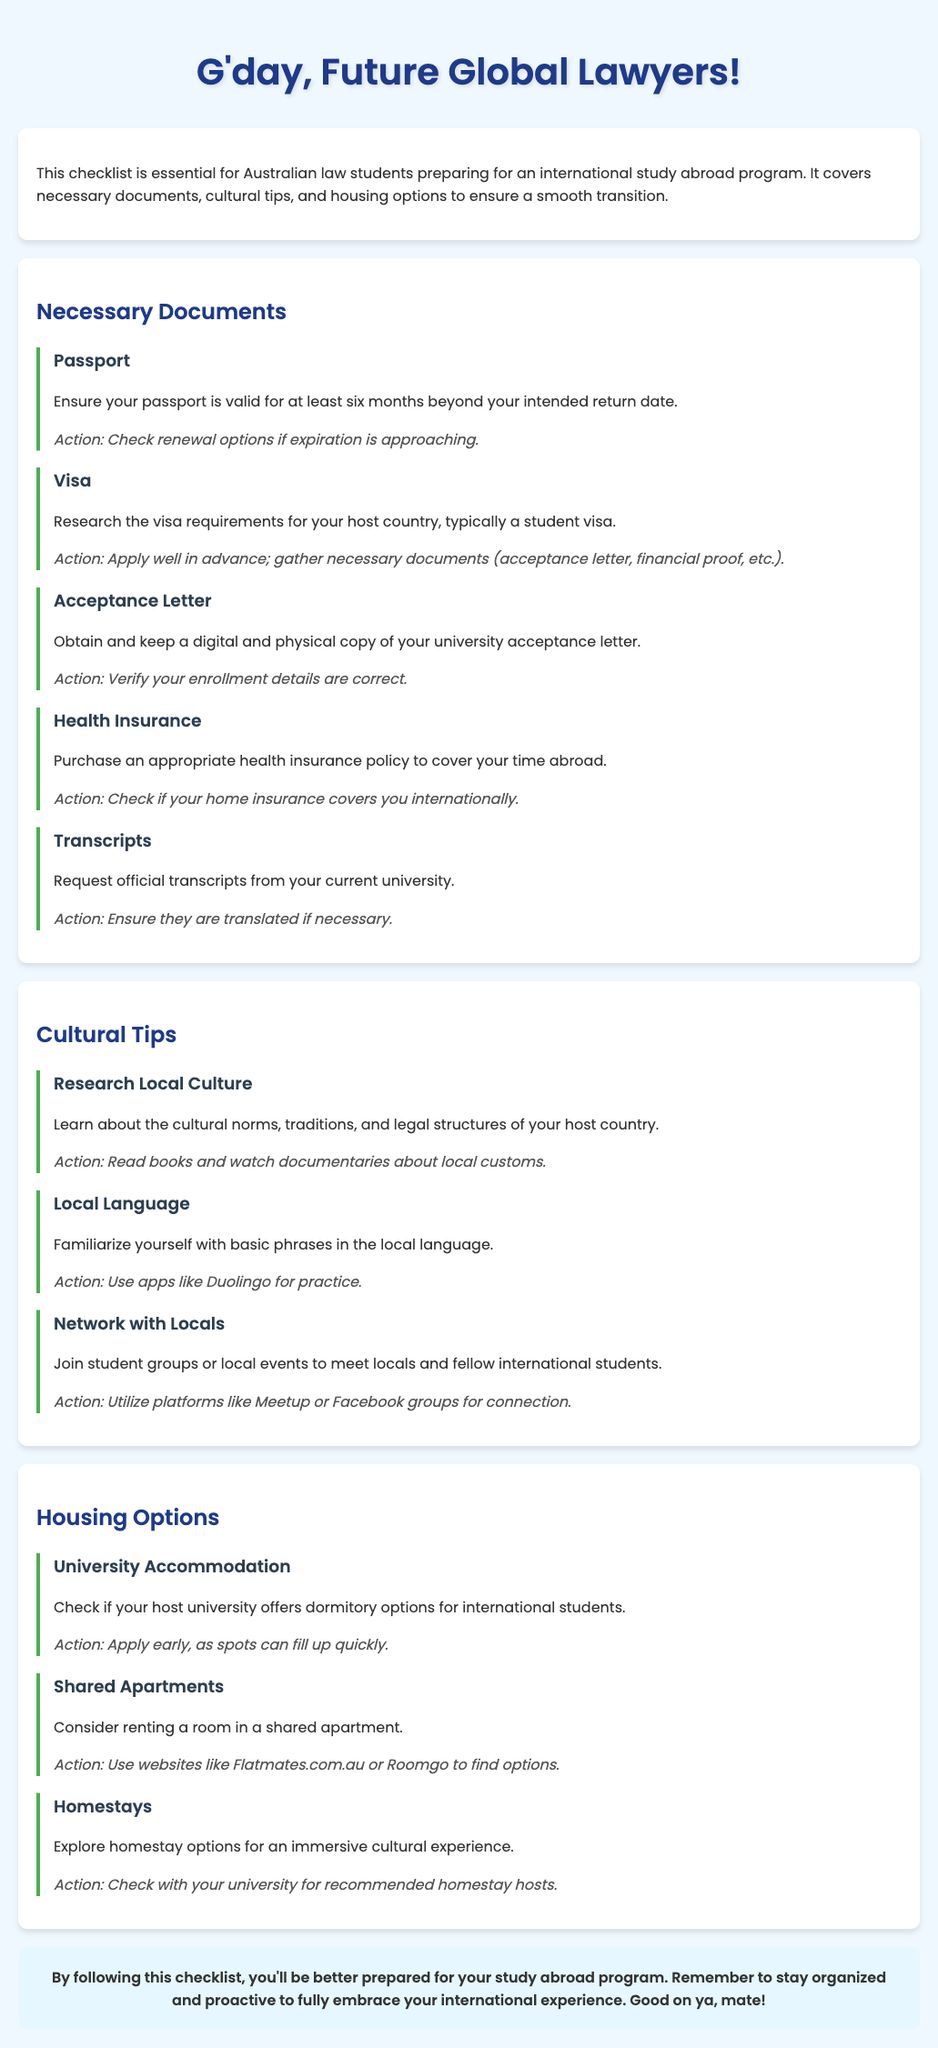what is the title of the document? The title of the document is prominently displayed in the header section of the page.
Answer: Study Abroad Checklist for Aussie Law Students how long should your passport be valid after your intended return date? The document states the validity requirement for passports in relation to travel.
Answer: six months what is one action you should take regarding your visa? The document lists specific actions for each necessary document, including the visa.
Answer: Apply well in advance which section discusses housing options? The document is organized into sections, and housing options are clearly defined under a specific section heading.
Answer: Housing Options what is one cultural tip mentioned in the document? The document includes various cultural tips under a dedicated section, outlining relevant advice for students.
Answer: Research Local Culture how can you connect with locals according to the cultural tips? The document provides suggestions for networking and engaging with the local community.
Answer: Join student groups what type of health insurance should you purchase? The checklist outlines the necessity of insurance and details what kind is required for study abroad.
Answer: Appropriate health insurance policy what should you verify for your acceptance letter? This action item specifies what students need to ensure regarding their acceptance documentation.
Answer: Enrollment details are correct how can you find shared apartment options? The document specifies platforms where students can look for shared accommodations.
Answer: Flatmates.com.au or Roomgo 